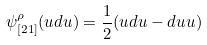Convert formula to latex. <formula><loc_0><loc_0><loc_500><loc_500>\psi _ { [ 2 1 ] } ^ { \rho } ( u d u ) = \frac { 1 } { 2 } ( u d u - d u u )</formula> 